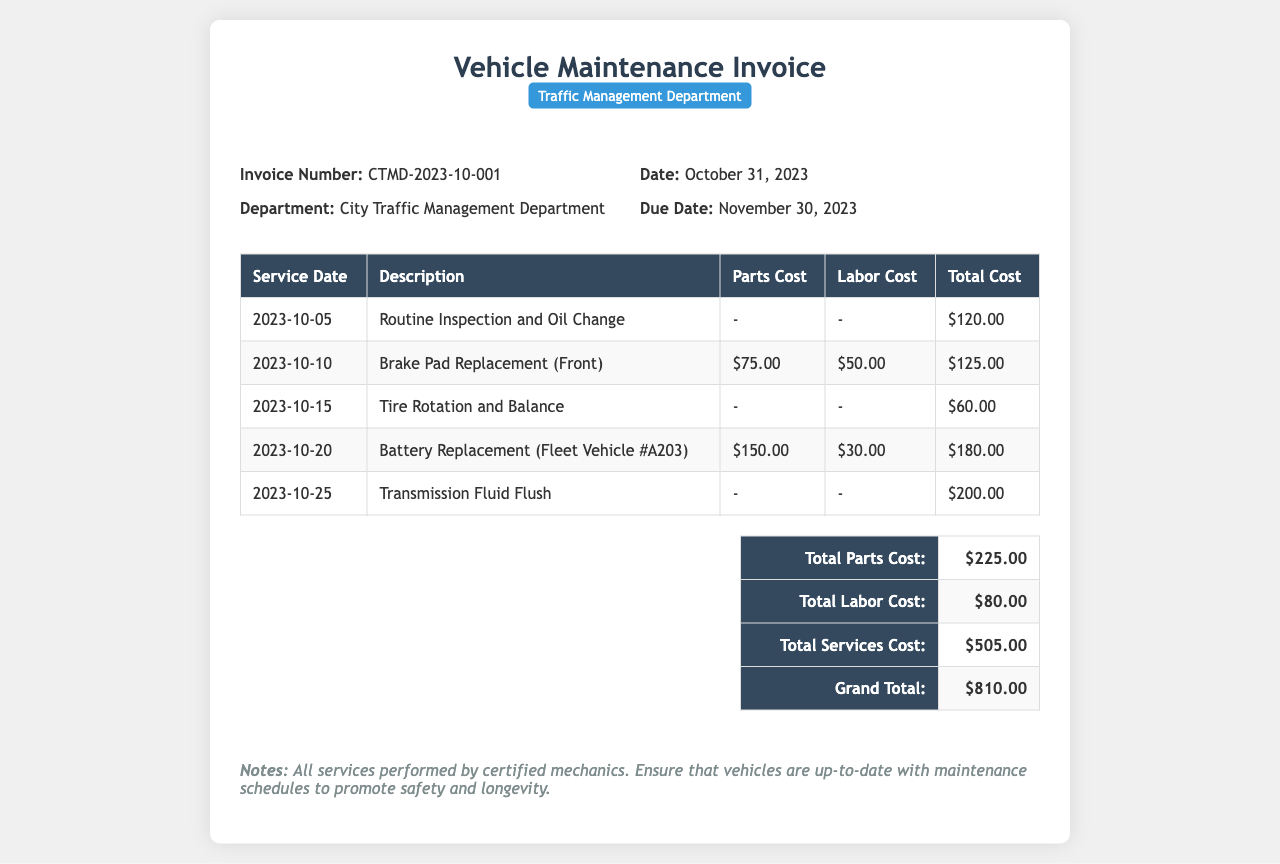What is the invoice number? The invoice number is listed in the document header as a unique identifier for this transaction.
Answer: CTMD-2023-10-001 What is the total parts cost? The total parts cost is calculated by summing all parts listed in the invoice.
Answer: $225.00 What was the date of the routine inspection? The service date for the routine inspection is provided in the service table under the corresponding entry for the routine inspection.
Answer: 2023-10-05 How much was spent on labor costs in total? The total labor cost is obtained by adding all labor costs from the service entries in the table.
Answer: $80.00 What is the grand total of the invoice? The grand total is the final amount owing for all services rendered, as indicated in the summary section of the document.
Answer: $810.00 What service was performed on October 10, 2023? The description of the service performed on this date is specifically mentioned in the service table.
Answer: Brake Pad Replacement (Front) What is the due date for this invoice? The due date is mentioned clearly to indicate when the payment must be made.
Answer: November 30, 2023 What does the notes section emphasize regarding vehicle maintenance? The notes section contains important information on best practices concerning vehicle maintenance highlighted in the document.
Answer: Ensure that vehicles are up-to-date with maintenance schedules to promote safety and longevity 